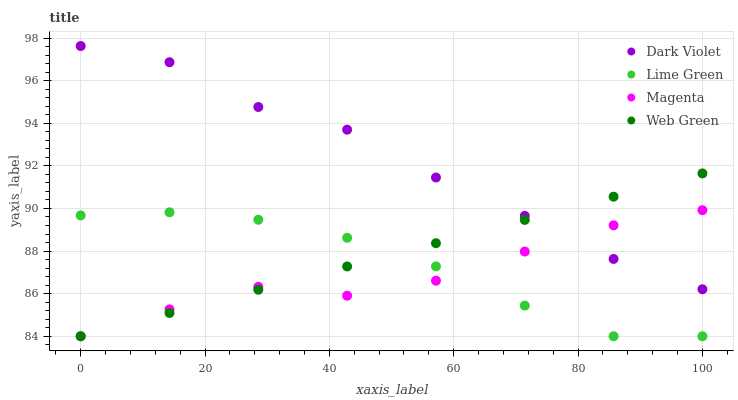Does Magenta have the minimum area under the curve?
Answer yes or no. Yes. Does Dark Violet have the maximum area under the curve?
Answer yes or no. Yes. Does Lime Green have the minimum area under the curve?
Answer yes or no. No. Does Lime Green have the maximum area under the curve?
Answer yes or no. No. Is Web Green the smoothest?
Answer yes or no. Yes. Is Dark Violet the roughest?
Answer yes or no. Yes. Is Lime Green the smoothest?
Answer yes or no. No. Is Lime Green the roughest?
Answer yes or no. No. Does Magenta have the lowest value?
Answer yes or no. Yes. Does Dark Violet have the lowest value?
Answer yes or no. No. Does Dark Violet have the highest value?
Answer yes or no. Yes. Does Web Green have the highest value?
Answer yes or no. No. Is Lime Green less than Dark Violet?
Answer yes or no. Yes. Is Dark Violet greater than Lime Green?
Answer yes or no. Yes. Does Web Green intersect Dark Violet?
Answer yes or no. Yes. Is Web Green less than Dark Violet?
Answer yes or no. No. Is Web Green greater than Dark Violet?
Answer yes or no. No. Does Lime Green intersect Dark Violet?
Answer yes or no. No. 